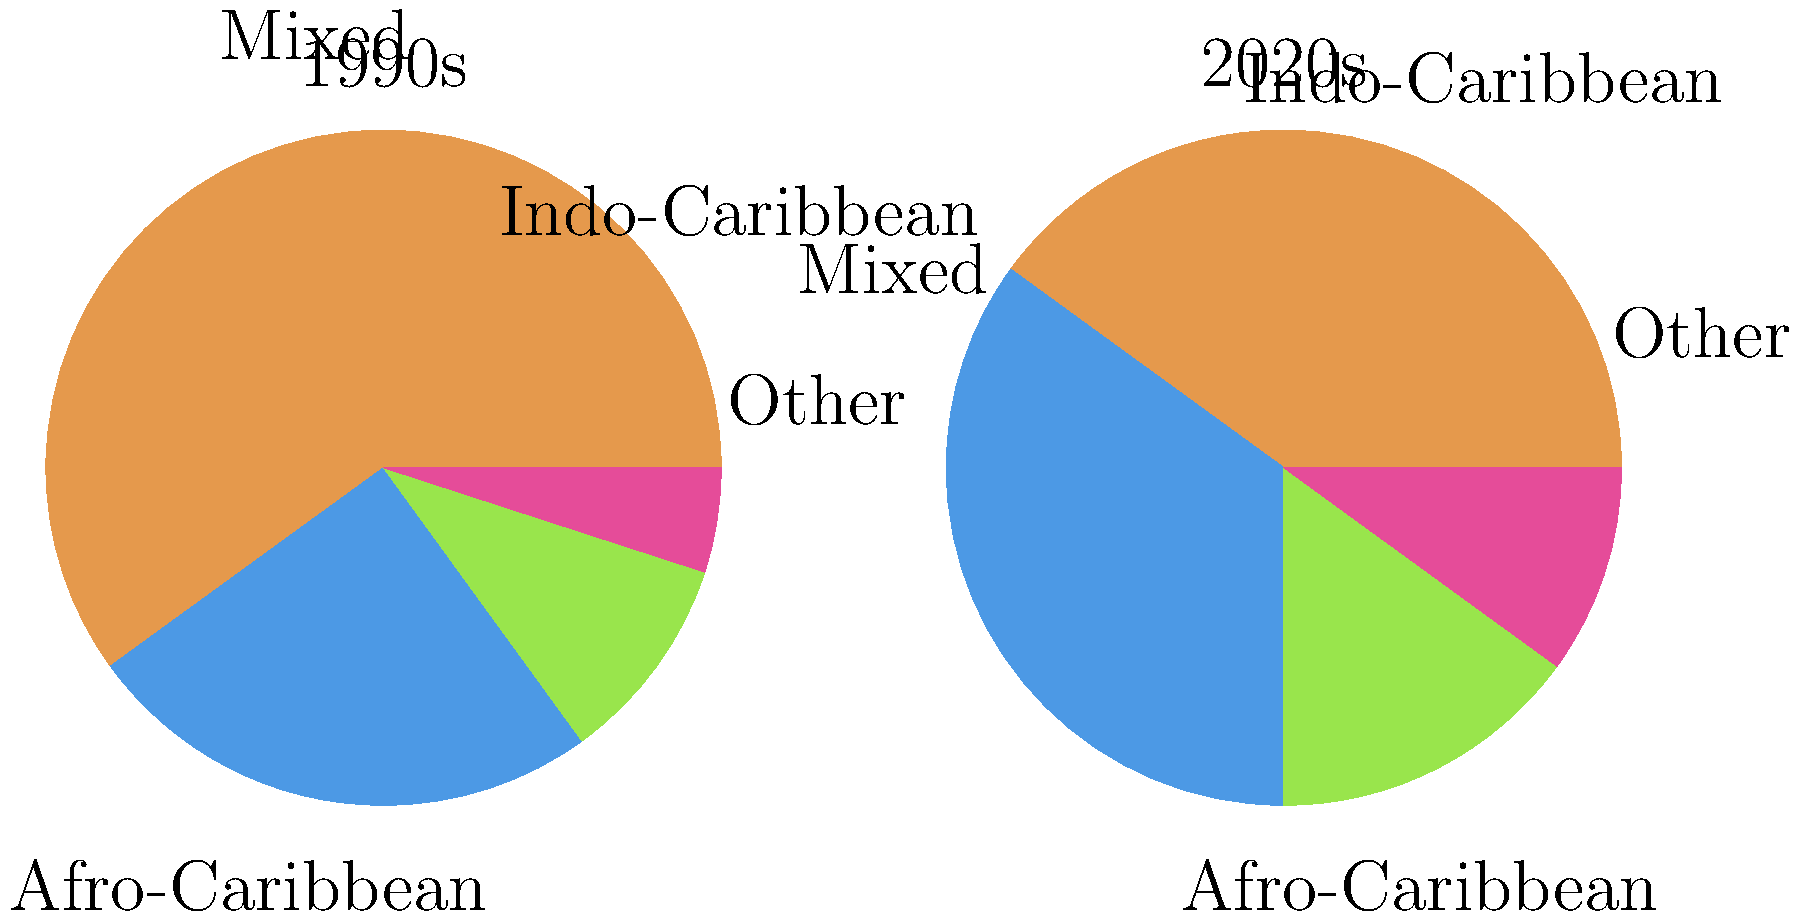Based on the pie charts showing racial demographics of Caribbean film casts in the 1990s and 2020s, which racial group experienced the largest percentage increase in representation from the 1990s to the 2020s? To determine which racial group experienced the largest percentage increase in representation, we need to compare the percentages for each group between the two decades:

1. Afro-Caribbean:
   1990s: 60%, 2020s: 40%
   Percentage change: (40% - 60%) / 60% * 100 = -33.33% (decrease)

2. Mixed:
   1990s: 25%, 2020s: 35%
   Percentage change: (35% - 25%) / 25% * 100 = +40% increase

3. Indo-Caribbean:
   1990s: 10%, 2020s: 15%
   Percentage change: (15% - 10%) / 10% * 100 = +50% increase

4. Other:
   1990s: 5%, 2020s: 10%
   Percentage change: (10% - 5%) / 5% * 100 = +100% increase

The "Other" category experienced the largest percentage increase at 100%, followed by Indo-Caribbean at 50%, Mixed at 40%, while Afro-Caribbean experienced a decrease.
Answer: Other 